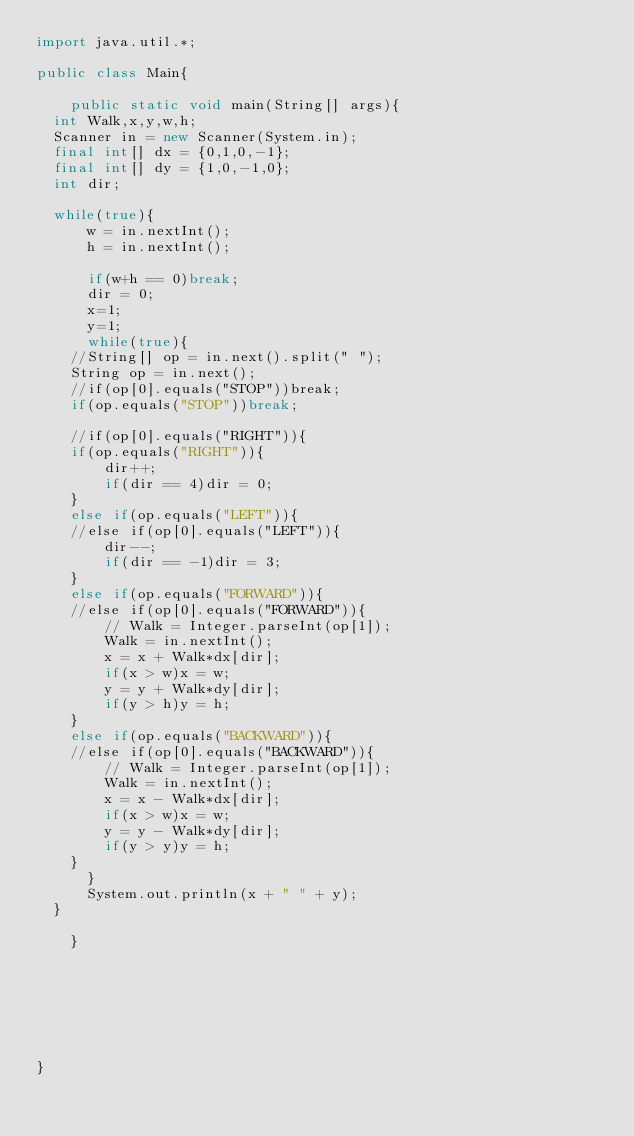Convert code to text. <code><loc_0><loc_0><loc_500><loc_500><_Java_>import java.util.*;

public class Main{

    public static void main(String[] args){
	int Walk,x,y,w,h;
	Scanner in = new Scanner(System.in);
	final int[] dx = {0,1,0,-1}; 
	final int[] dy = {1,0,-1,0};
	int dir;
       
	while(true){
	    w = in.nextInt();
	    h = in.nextInt();	       

	    if(w+h == 0)break;
	    dir = 0;
	    x=1;
	    y=1;
	    while(true){
		//String[] op = in.next().split(" ");
		String op = in.next();
		//if(op[0].equals("STOP"))break;
		if(op.equals("STOP"))break;

		//if(op[0].equals("RIGHT")){
		if(op.equals("RIGHT")){
		    dir++;
		    if(dir == 4)dir = 0;
		}
		else if(op.equals("LEFT")){
		//else if(op[0].equals("LEFT")){
		    dir--;
		    if(dir == -1)dir = 3;
		}
		else if(op.equals("FORWARD")){
		//else if(op[0].equals("FORWARD")){
		    // Walk = Integer.parseInt(op[1]); 
		    Walk = in.nextInt();
		    x = x + Walk*dx[dir];
		    if(x > w)x = w;
		    y = y + Walk*dy[dir];
		    if(y > h)y = h;
		}
		else if(op.equals("BACKWARD")){
		//else if(op[0].equals("BACKWARD")){
		    // Walk = Integer.parseInt(op[1]);
		    Walk = in.nextInt();
		    x = x - Walk*dx[dir];
		    if(x > w)x = w;
		    y = y - Walk*dy[dir];
		    if(y > y)y = h;
		}
	    }
	    System.out.println(x + " " + y);
	}

    }







}</code> 